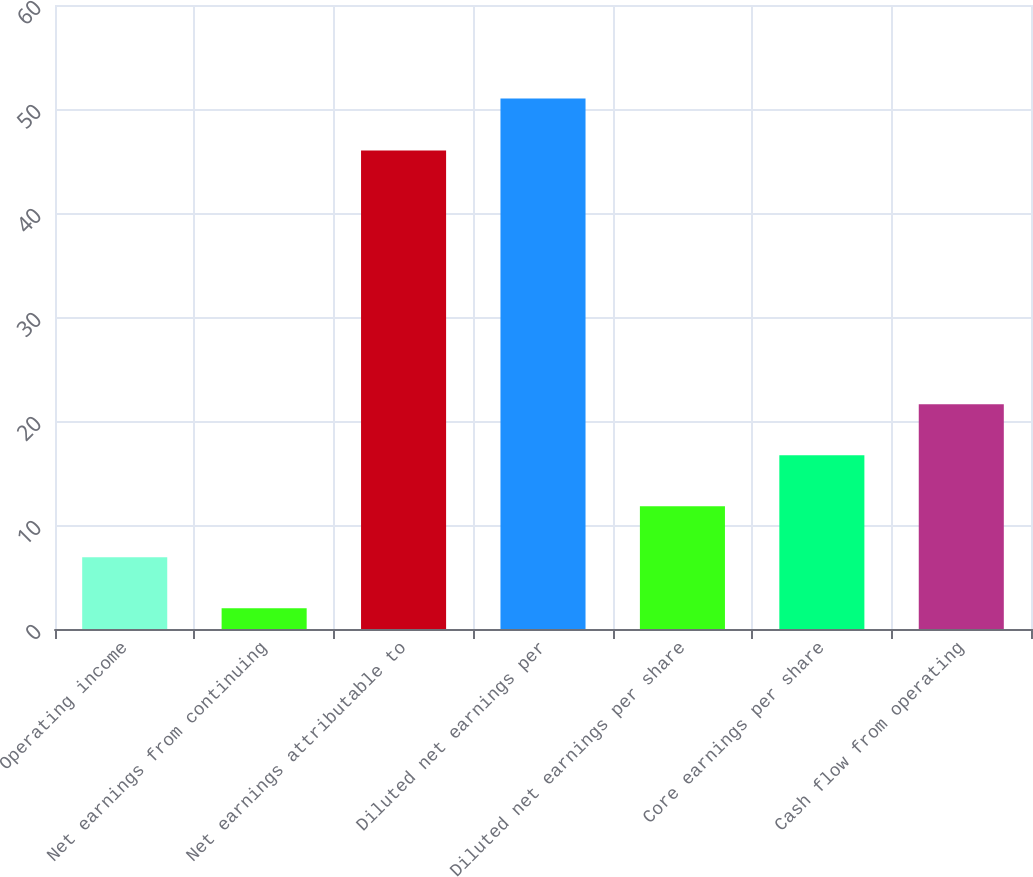<chart> <loc_0><loc_0><loc_500><loc_500><bar_chart><fcel>Operating income<fcel>Net earnings from continuing<fcel>Net earnings attributable to<fcel>Diluted net earnings per<fcel>Diluted net earnings per share<fcel>Core earnings per share<fcel>Cash flow from operating<nl><fcel>6.9<fcel>2<fcel>46<fcel>51<fcel>11.8<fcel>16.7<fcel>21.6<nl></chart> 